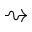Convert formula to latex. <formula><loc_0><loc_0><loc_500><loc_500>\right s q u i g a r r o w</formula> 